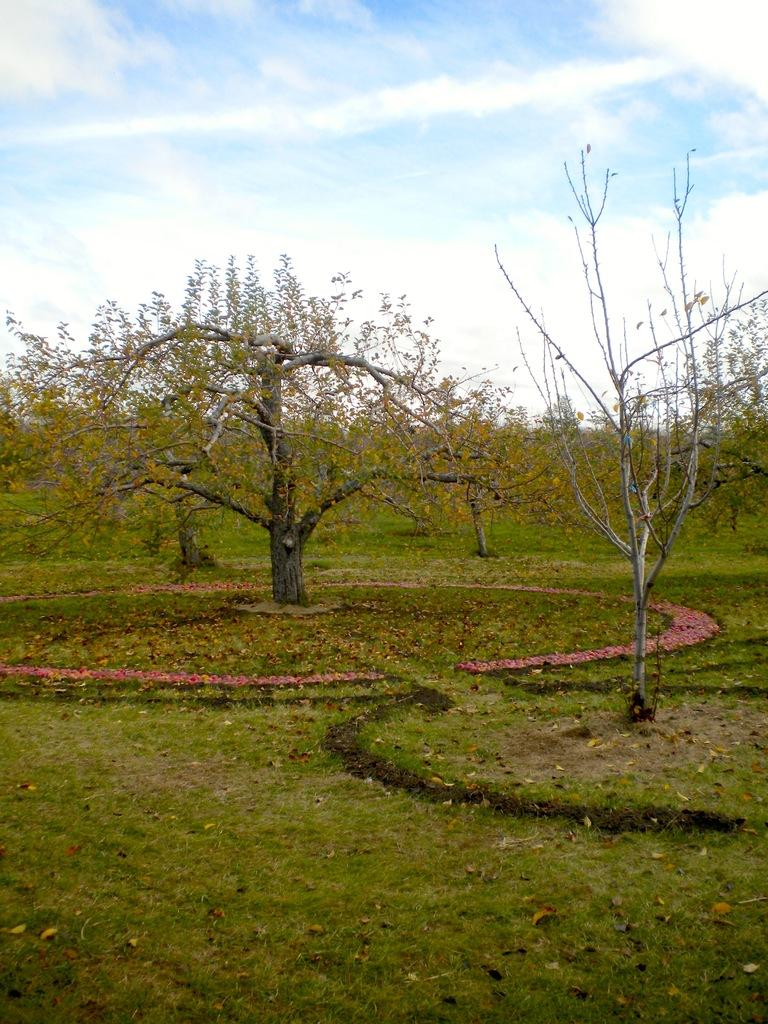What type of vegetation is visible in the image? There is grass in the image. What other natural elements can be seen in the image? There are trees in the image. What is visible in the sky in the image? There are clouds visible in the image. How many pizzas can be seen on the grass in the image? There are no pizzas present in the image. What color is the sock hanging on the tree in the image? There is no sock present in the image. 